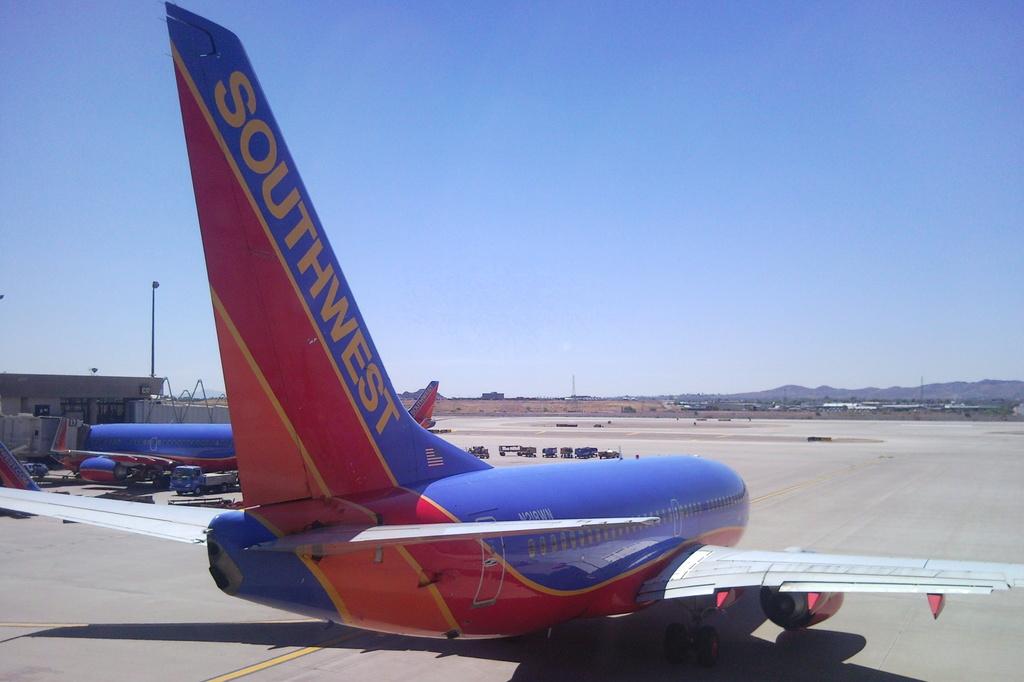Which flight provider is this?
Your answer should be very brief. Southwest. 